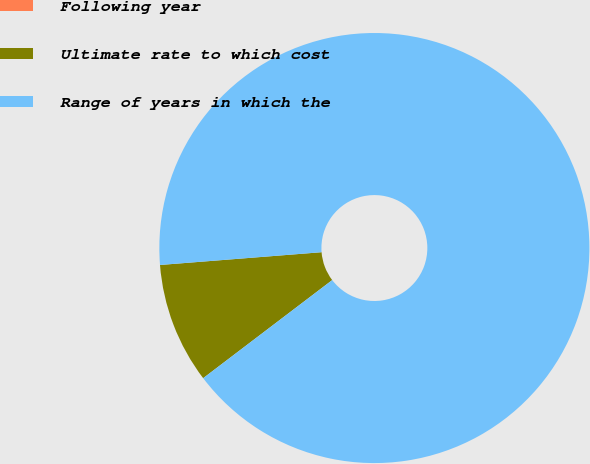Convert chart to OTSL. <chart><loc_0><loc_0><loc_500><loc_500><pie_chart><fcel>Following year<fcel>Ultimate rate to which cost<fcel>Range of years in which the<nl><fcel>0.0%<fcel>9.09%<fcel>90.91%<nl></chart> 